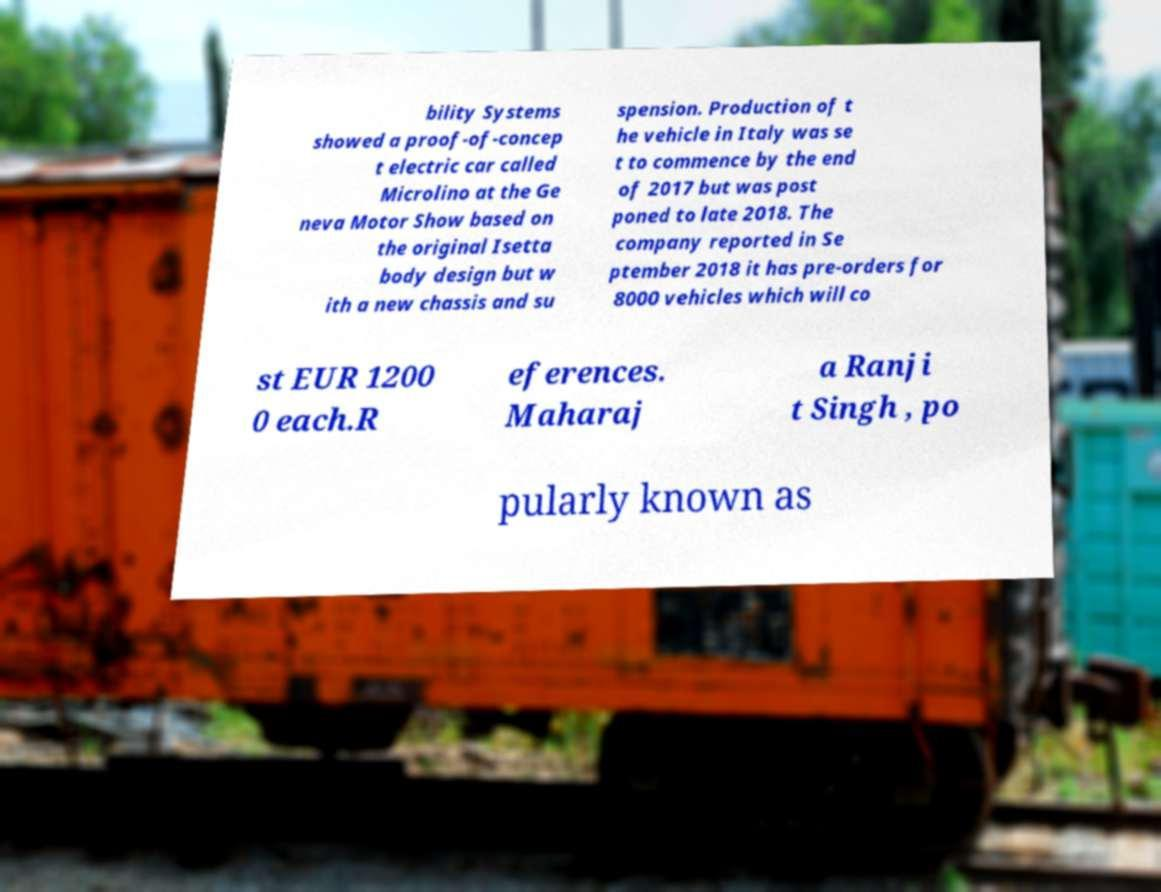I need the written content from this picture converted into text. Can you do that? bility Systems showed a proof-of-concep t electric car called Microlino at the Ge neva Motor Show based on the original Isetta body design but w ith a new chassis and su spension. Production of t he vehicle in Italy was se t to commence by the end of 2017 but was post poned to late 2018. The company reported in Se ptember 2018 it has pre-orders for 8000 vehicles which will co st EUR 1200 0 each.R eferences. Maharaj a Ranji t Singh , po pularly known as 